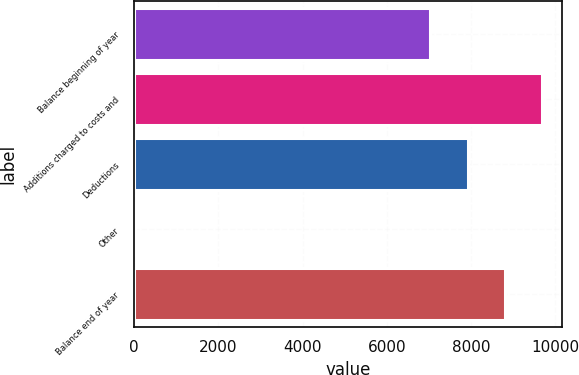Convert chart to OTSL. <chart><loc_0><loc_0><loc_500><loc_500><bar_chart><fcel>Balance beginning of year<fcel>Additions charged to costs and<fcel>Deductions<fcel>Other<fcel>Balance end of year<nl><fcel>7038<fcel>9685.5<fcel>7920.5<fcel>21<fcel>8803<nl></chart> 